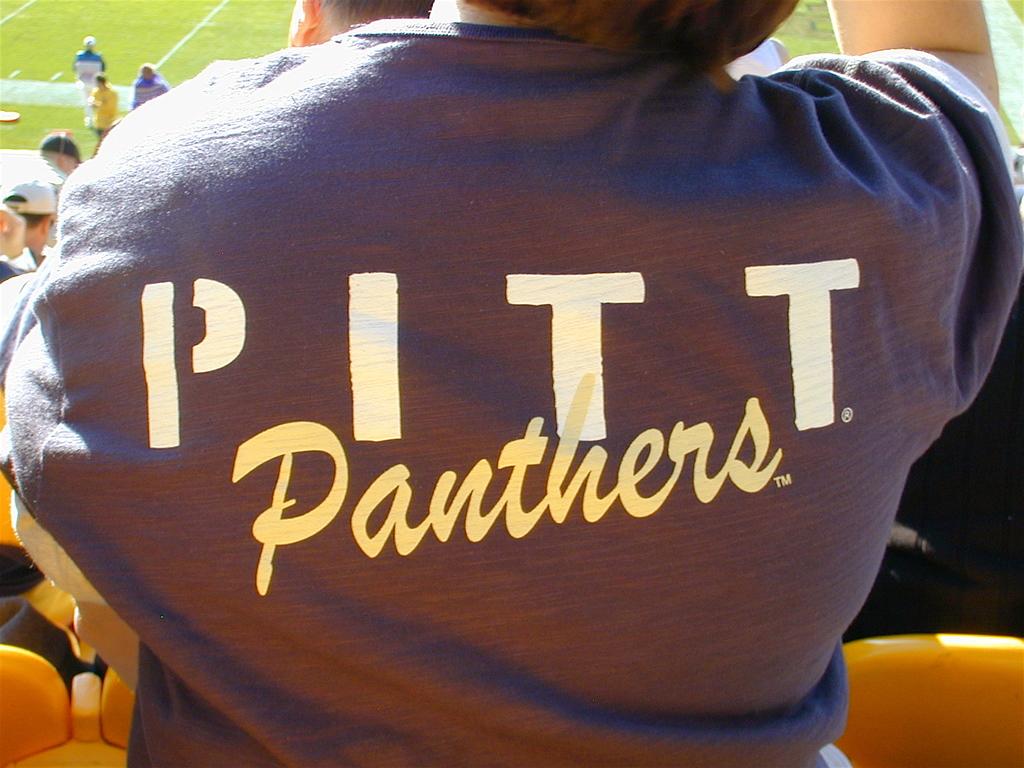What team is on this jacket?
Ensure brevity in your answer.  Pitt panthers. What does the shirt say?
Provide a succinct answer. Pitt panthers. 